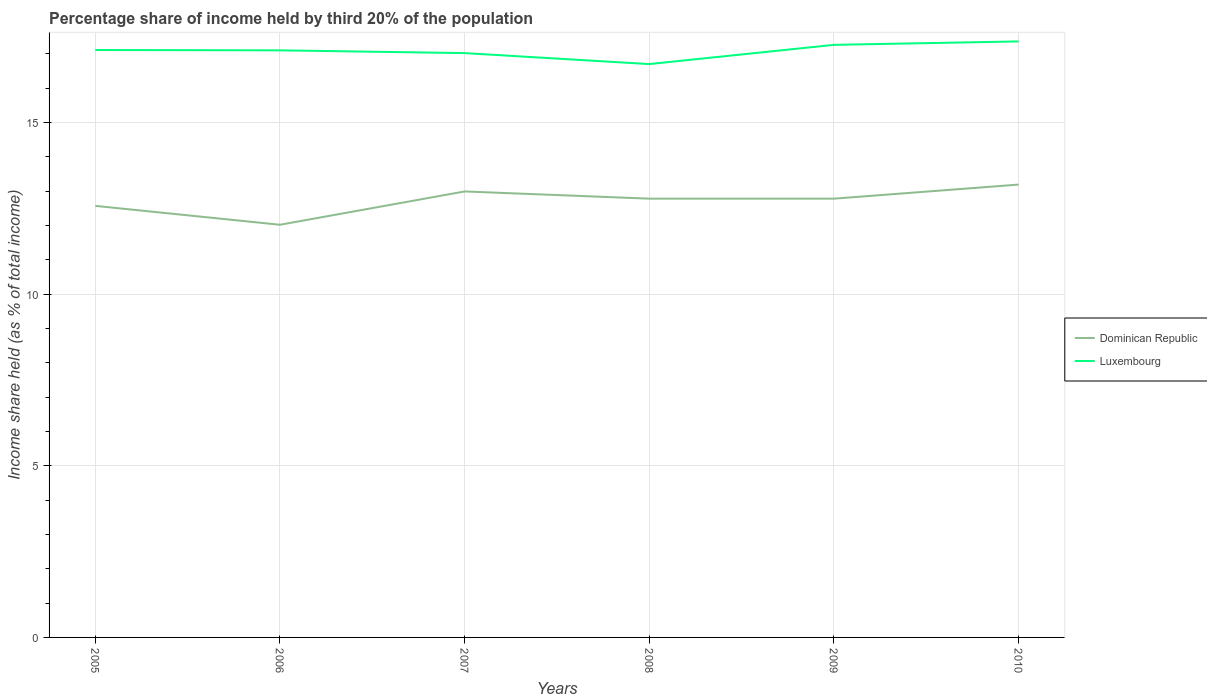In which year was the share of income held by third 20% of the population in Dominican Republic maximum?
Provide a short and direct response. 2006. What is the total share of income held by third 20% of the population in Dominican Republic in the graph?
Your answer should be very brief. -0.76. What is the difference between the highest and the second highest share of income held by third 20% of the population in Luxembourg?
Provide a succinct answer. 0.66. What is the difference between the highest and the lowest share of income held by third 20% of the population in Dominican Republic?
Provide a short and direct response. 4. How many lines are there?
Your answer should be very brief. 2. How many years are there in the graph?
Provide a succinct answer. 6. What is the difference between two consecutive major ticks on the Y-axis?
Give a very brief answer. 5. Does the graph contain any zero values?
Your response must be concise. No. How many legend labels are there?
Ensure brevity in your answer.  2. How are the legend labels stacked?
Ensure brevity in your answer.  Vertical. What is the title of the graph?
Ensure brevity in your answer.  Percentage share of income held by third 20% of the population. Does "Caribbean small states" appear as one of the legend labels in the graph?
Give a very brief answer. No. What is the label or title of the Y-axis?
Provide a short and direct response. Income share held (as % of total income). What is the Income share held (as % of total income) in Dominican Republic in 2005?
Provide a short and direct response. 12.57. What is the Income share held (as % of total income) in Luxembourg in 2005?
Your answer should be very brief. 17.11. What is the Income share held (as % of total income) of Dominican Republic in 2006?
Offer a very short reply. 12.02. What is the Income share held (as % of total income) of Luxembourg in 2006?
Ensure brevity in your answer.  17.1. What is the Income share held (as % of total income) of Dominican Republic in 2007?
Give a very brief answer. 12.99. What is the Income share held (as % of total income) in Luxembourg in 2007?
Provide a short and direct response. 17.02. What is the Income share held (as % of total income) of Dominican Republic in 2008?
Your answer should be compact. 12.78. What is the Income share held (as % of total income) in Dominican Republic in 2009?
Your response must be concise. 12.78. What is the Income share held (as % of total income) in Luxembourg in 2009?
Your response must be concise. 17.26. What is the Income share held (as % of total income) in Dominican Republic in 2010?
Offer a terse response. 13.19. What is the Income share held (as % of total income) in Luxembourg in 2010?
Give a very brief answer. 17.36. Across all years, what is the maximum Income share held (as % of total income) in Dominican Republic?
Give a very brief answer. 13.19. Across all years, what is the maximum Income share held (as % of total income) in Luxembourg?
Make the answer very short. 17.36. Across all years, what is the minimum Income share held (as % of total income) of Dominican Republic?
Provide a succinct answer. 12.02. What is the total Income share held (as % of total income) of Dominican Republic in the graph?
Make the answer very short. 76.33. What is the total Income share held (as % of total income) of Luxembourg in the graph?
Provide a short and direct response. 102.55. What is the difference between the Income share held (as % of total income) in Dominican Republic in 2005 and that in 2006?
Your answer should be compact. 0.55. What is the difference between the Income share held (as % of total income) in Dominican Republic in 2005 and that in 2007?
Provide a succinct answer. -0.42. What is the difference between the Income share held (as % of total income) of Luxembourg in 2005 and that in 2007?
Provide a short and direct response. 0.09. What is the difference between the Income share held (as % of total income) of Dominican Republic in 2005 and that in 2008?
Your answer should be compact. -0.21. What is the difference between the Income share held (as % of total income) in Luxembourg in 2005 and that in 2008?
Provide a short and direct response. 0.41. What is the difference between the Income share held (as % of total income) of Dominican Republic in 2005 and that in 2009?
Make the answer very short. -0.21. What is the difference between the Income share held (as % of total income) of Dominican Republic in 2005 and that in 2010?
Your answer should be compact. -0.62. What is the difference between the Income share held (as % of total income) of Luxembourg in 2005 and that in 2010?
Your answer should be very brief. -0.25. What is the difference between the Income share held (as % of total income) of Dominican Republic in 2006 and that in 2007?
Ensure brevity in your answer.  -0.97. What is the difference between the Income share held (as % of total income) of Dominican Republic in 2006 and that in 2008?
Your answer should be very brief. -0.76. What is the difference between the Income share held (as % of total income) of Dominican Republic in 2006 and that in 2009?
Offer a terse response. -0.76. What is the difference between the Income share held (as % of total income) of Luxembourg in 2006 and that in 2009?
Provide a short and direct response. -0.16. What is the difference between the Income share held (as % of total income) of Dominican Republic in 2006 and that in 2010?
Your response must be concise. -1.17. What is the difference between the Income share held (as % of total income) of Luxembourg in 2006 and that in 2010?
Provide a succinct answer. -0.26. What is the difference between the Income share held (as % of total income) of Dominican Republic in 2007 and that in 2008?
Your response must be concise. 0.21. What is the difference between the Income share held (as % of total income) of Luxembourg in 2007 and that in 2008?
Your answer should be very brief. 0.32. What is the difference between the Income share held (as % of total income) in Dominican Republic in 2007 and that in 2009?
Ensure brevity in your answer.  0.21. What is the difference between the Income share held (as % of total income) in Luxembourg in 2007 and that in 2009?
Offer a very short reply. -0.24. What is the difference between the Income share held (as % of total income) of Dominican Republic in 2007 and that in 2010?
Your answer should be compact. -0.2. What is the difference between the Income share held (as % of total income) of Luxembourg in 2007 and that in 2010?
Your answer should be compact. -0.34. What is the difference between the Income share held (as % of total income) in Luxembourg in 2008 and that in 2009?
Give a very brief answer. -0.56. What is the difference between the Income share held (as % of total income) of Dominican Republic in 2008 and that in 2010?
Keep it short and to the point. -0.41. What is the difference between the Income share held (as % of total income) in Luxembourg in 2008 and that in 2010?
Keep it short and to the point. -0.66. What is the difference between the Income share held (as % of total income) of Dominican Republic in 2009 and that in 2010?
Ensure brevity in your answer.  -0.41. What is the difference between the Income share held (as % of total income) in Dominican Republic in 2005 and the Income share held (as % of total income) in Luxembourg in 2006?
Offer a very short reply. -4.53. What is the difference between the Income share held (as % of total income) in Dominican Republic in 2005 and the Income share held (as % of total income) in Luxembourg in 2007?
Your answer should be compact. -4.45. What is the difference between the Income share held (as % of total income) in Dominican Republic in 2005 and the Income share held (as % of total income) in Luxembourg in 2008?
Your answer should be very brief. -4.13. What is the difference between the Income share held (as % of total income) of Dominican Republic in 2005 and the Income share held (as % of total income) of Luxembourg in 2009?
Keep it short and to the point. -4.69. What is the difference between the Income share held (as % of total income) of Dominican Republic in 2005 and the Income share held (as % of total income) of Luxembourg in 2010?
Give a very brief answer. -4.79. What is the difference between the Income share held (as % of total income) in Dominican Republic in 2006 and the Income share held (as % of total income) in Luxembourg in 2008?
Make the answer very short. -4.68. What is the difference between the Income share held (as % of total income) in Dominican Republic in 2006 and the Income share held (as % of total income) in Luxembourg in 2009?
Provide a succinct answer. -5.24. What is the difference between the Income share held (as % of total income) of Dominican Republic in 2006 and the Income share held (as % of total income) of Luxembourg in 2010?
Your answer should be compact. -5.34. What is the difference between the Income share held (as % of total income) of Dominican Republic in 2007 and the Income share held (as % of total income) of Luxembourg in 2008?
Provide a short and direct response. -3.71. What is the difference between the Income share held (as % of total income) of Dominican Republic in 2007 and the Income share held (as % of total income) of Luxembourg in 2009?
Offer a terse response. -4.27. What is the difference between the Income share held (as % of total income) in Dominican Republic in 2007 and the Income share held (as % of total income) in Luxembourg in 2010?
Your answer should be very brief. -4.37. What is the difference between the Income share held (as % of total income) in Dominican Republic in 2008 and the Income share held (as % of total income) in Luxembourg in 2009?
Give a very brief answer. -4.48. What is the difference between the Income share held (as % of total income) in Dominican Republic in 2008 and the Income share held (as % of total income) in Luxembourg in 2010?
Make the answer very short. -4.58. What is the difference between the Income share held (as % of total income) of Dominican Republic in 2009 and the Income share held (as % of total income) of Luxembourg in 2010?
Your answer should be very brief. -4.58. What is the average Income share held (as % of total income) in Dominican Republic per year?
Provide a short and direct response. 12.72. What is the average Income share held (as % of total income) in Luxembourg per year?
Provide a succinct answer. 17.09. In the year 2005, what is the difference between the Income share held (as % of total income) in Dominican Republic and Income share held (as % of total income) in Luxembourg?
Your answer should be compact. -4.54. In the year 2006, what is the difference between the Income share held (as % of total income) of Dominican Republic and Income share held (as % of total income) of Luxembourg?
Your answer should be compact. -5.08. In the year 2007, what is the difference between the Income share held (as % of total income) of Dominican Republic and Income share held (as % of total income) of Luxembourg?
Your response must be concise. -4.03. In the year 2008, what is the difference between the Income share held (as % of total income) in Dominican Republic and Income share held (as % of total income) in Luxembourg?
Provide a short and direct response. -3.92. In the year 2009, what is the difference between the Income share held (as % of total income) of Dominican Republic and Income share held (as % of total income) of Luxembourg?
Ensure brevity in your answer.  -4.48. In the year 2010, what is the difference between the Income share held (as % of total income) of Dominican Republic and Income share held (as % of total income) of Luxembourg?
Your answer should be very brief. -4.17. What is the ratio of the Income share held (as % of total income) in Dominican Republic in 2005 to that in 2006?
Your response must be concise. 1.05. What is the ratio of the Income share held (as % of total income) of Dominican Republic in 2005 to that in 2008?
Your response must be concise. 0.98. What is the ratio of the Income share held (as % of total income) in Luxembourg in 2005 to that in 2008?
Ensure brevity in your answer.  1.02. What is the ratio of the Income share held (as % of total income) of Dominican Republic in 2005 to that in 2009?
Your answer should be very brief. 0.98. What is the ratio of the Income share held (as % of total income) in Dominican Republic in 2005 to that in 2010?
Offer a very short reply. 0.95. What is the ratio of the Income share held (as % of total income) in Luxembourg in 2005 to that in 2010?
Provide a succinct answer. 0.99. What is the ratio of the Income share held (as % of total income) in Dominican Republic in 2006 to that in 2007?
Give a very brief answer. 0.93. What is the ratio of the Income share held (as % of total income) in Luxembourg in 2006 to that in 2007?
Provide a short and direct response. 1. What is the ratio of the Income share held (as % of total income) in Dominican Republic in 2006 to that in 2008?
Offer a very short reply. 0.94. What is the ratio of the Income share held (as % of total income) of Luxembourg in 2006 to that in 2008?
Your answer should be compact. 1.02. What is the ratio of the Income share held (as % of total income) in Dominican Republic in 2006 to that in 2009?
Provide a short and direct response. 0.94. What is the ratio of the Income share held (as % of total income) of Luxembourg in 2006 to that in 2009?
Offer a very short reply. 0.99. What is the ratio of the Income share held (as % of total income) in Dominican Republic in 2006 to that in 2010?
Offer a very short reply. 0.91. What is the ratio of the Income share held (as % of total income) in Dominican Republic in 2007 to that in 2008?
Your answer should be very brief. 1.02. What is the ratio of the Income share held (as % of total income) of Luxembourg in 2007 to that in 2008?
Your answer should be compact. 1.02. What is the ratio of the Income share held (as % of total income) of Dominican Republic in 2007 to that in 2009?
Provide a succinct answer. 1.02. What is the ratio of the Income share held (as % of total income) of Luxembourg in 2007 to that in 2009?
Offer a terse response. 0.99. What is the ratio of the Income share held (as % of total income) in Luxembourg in 2007 to that in 2010?
Make the answer very short. 0.98. What is the ratio of the Income share held (as % of total income) in Dominican Republic in 2008 to that in 2009?
Your answer should be very brief. 1. What is the ratio of the Income share held (as % of total income) of Luxembourg in 2008 to that in 2009?
Give a very brief answer. 0.97. What is the ratio of the Income share held (as % of total income) in Dominican Republic in 2008 to that in 2010?
Provide a short and direct response. 0.97. What is the ratio of the Income share held (as % of total income) in Luxembourg in 2008 to that in 2010?
Provide a succinct answer. 0.96. What is the ratio of the Income share held (as % of total income) of Dominican Republic in 2009 to that in 2010?
Keep it short and to the point. 0.97. What is the ratio of the Income share held (as % of total income) of Luxembourg in 2009 to that in 2010?
Your answer should be compact. 0.99. What is the difference between the highest and the second highest Income share held (as % of total income) in Luxembourg?
Provide a short and direct response. 0.1. What is the difference between the highest and the lowest Income share held (as % of total income) of Dominican Republic?
Your answer should be compact. 1.17. What is the difference between the highest and the lowest Income share held (as % of total income) of Luxembourg?
Make the answer very short. 0.66. 